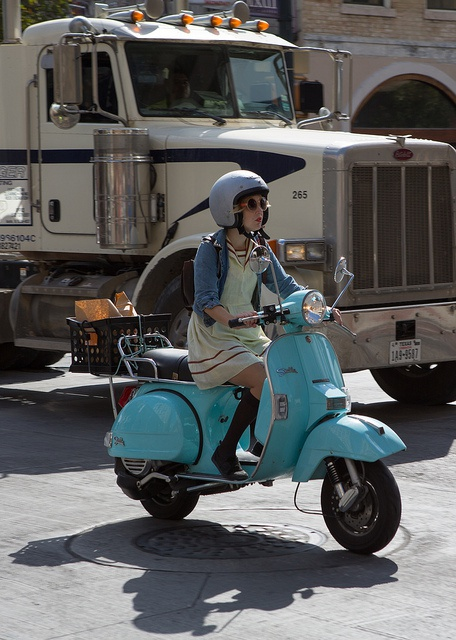Describe the objects in this image and their specific colors. I can see truck in black, gray, and darkgray tones, motorcycle in black, teal, and gray tones, people in black, gray, navy, and maroon tones, and people in black tones in this image. 